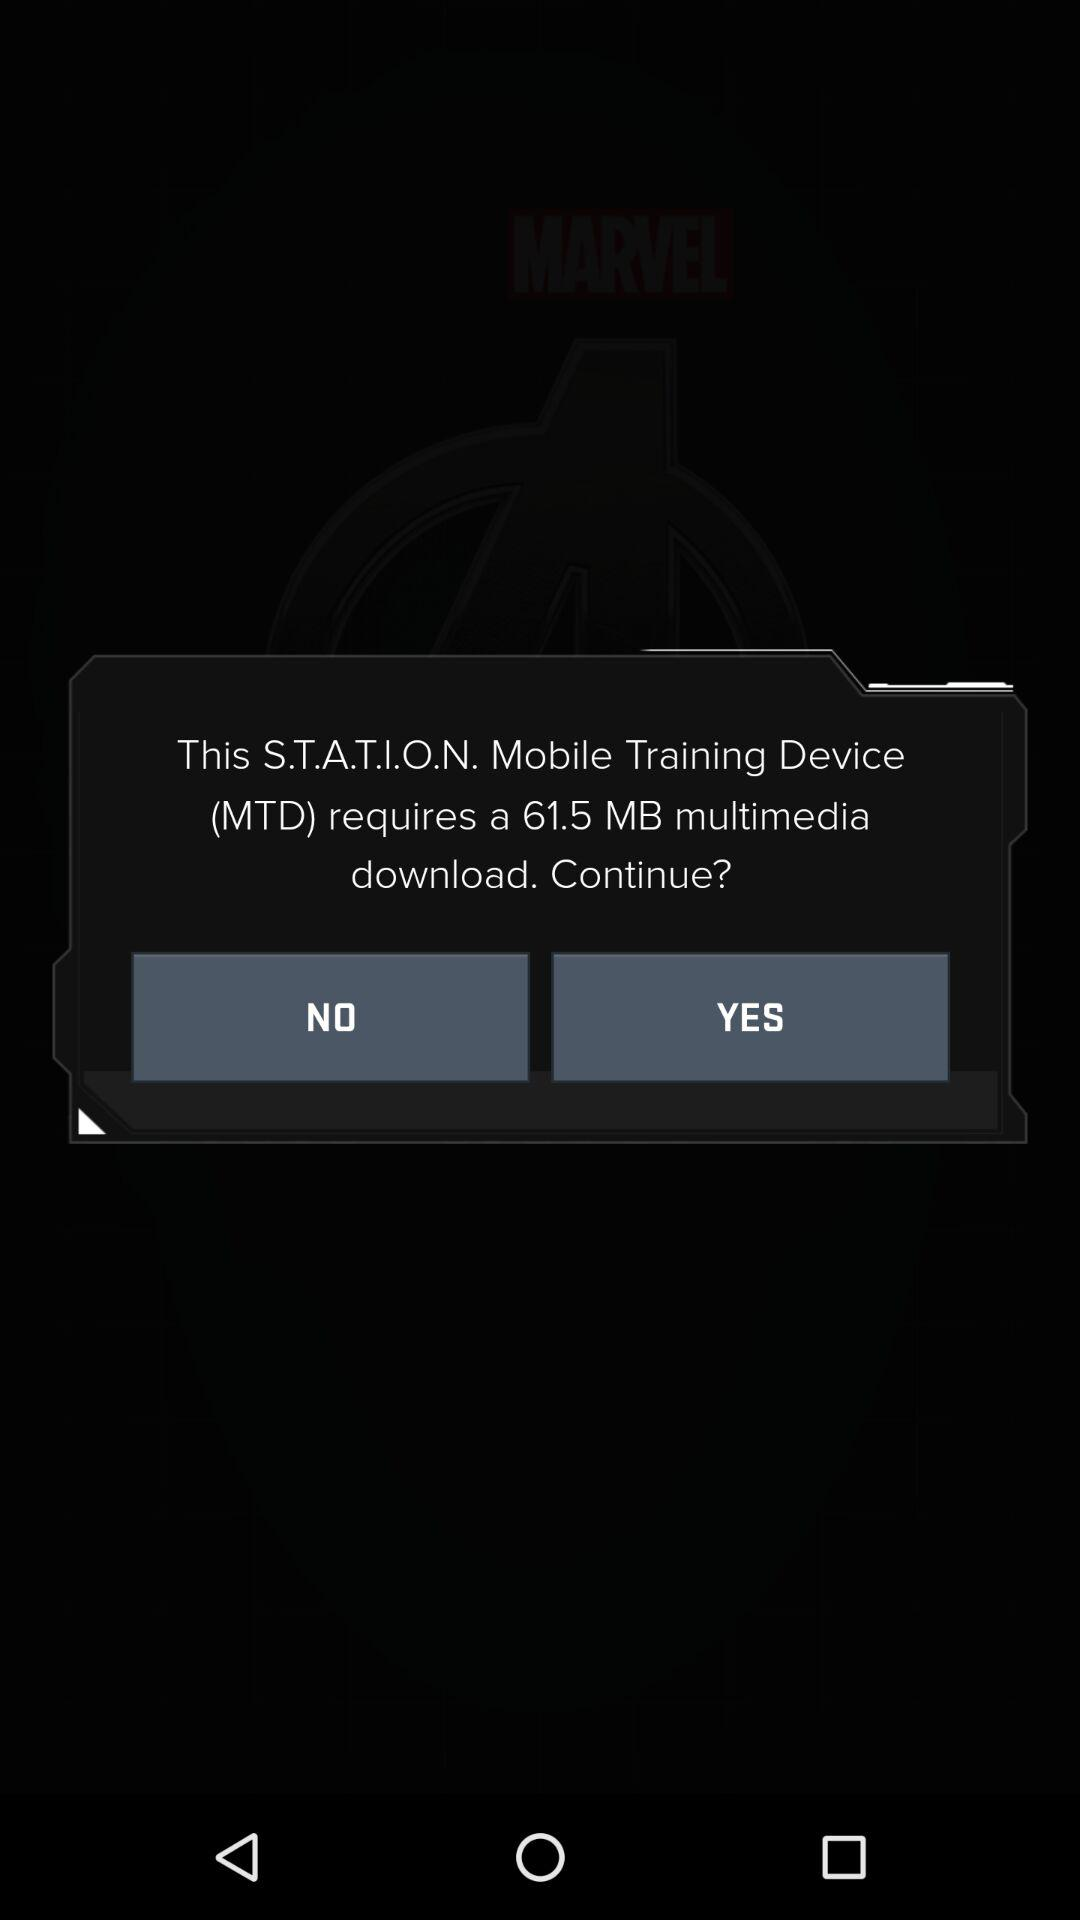What is the app name?
When the provided information is insufficient, respond with <no answer>. <no answer> 